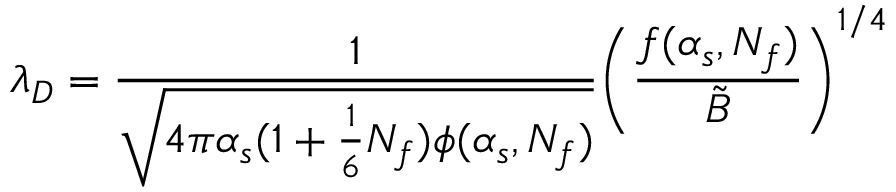<formula> <loc_0><loc_0><loc_500><loc_500>\lambda _ { D } = { \frac { 1 } { \sqrt { 4 \pi \alpha _ { s } ( 1 + { \frac { 1 } { 6 } } N _ { f } ) \phi ( \alpha _ { s } , N _ { f } ) } } } \left ( { \frac { f ( \alpha _ { s } , N _ { f } ) } { \tilde { B } } } \right ) ^ { 1 / 4 }</formula> 